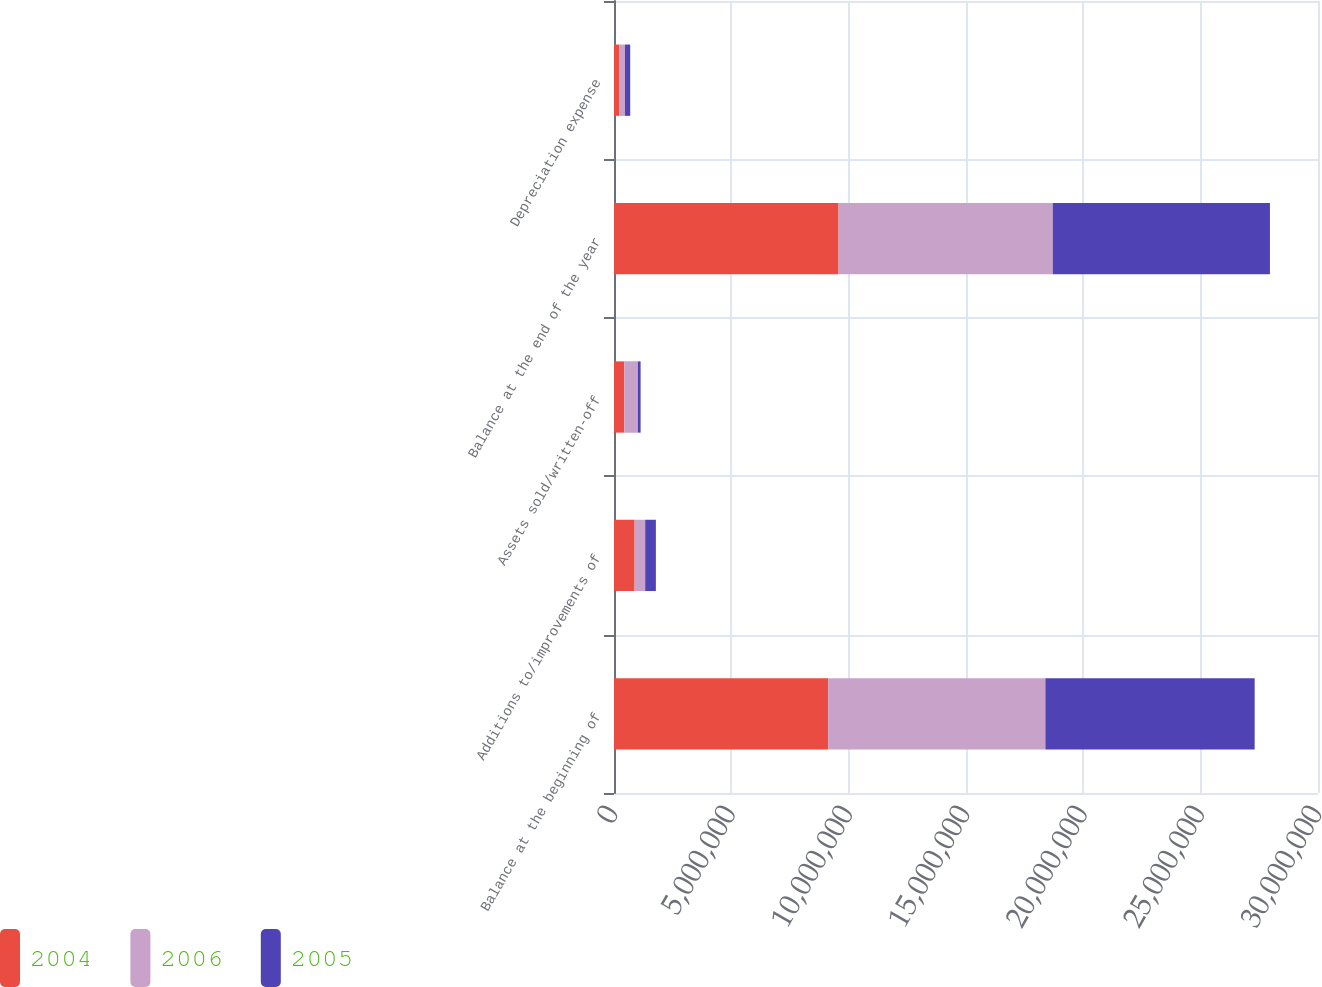Convert chart. <chart><loc_0><loc_0><loc_500><loc_500><stacked_bar_chart><ecel><fcel>Balance at the beginning of<fcel>Additions to/improvements of<fcel>Assets sold/written-off<fcel>Balance at the end of the year<fcel>Depreciation expense<nl><fcel>2004<fcel>9.12681e+06<fcel>878670<fcel>436987<fcel>9.5685e+06<fcel>236883<nl><fcel>2006<fcel>9.25664e+06<fcel>450641<fcel>580466<fcel>9.12681e+06<fcel>231790<nl><fcel>2005<fcel>8.91779e+06<fcel>454806<fcel>115955<fcel>9.25664e+06<fcel>222142<nl></chart> 